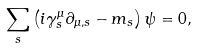Convert formula to latex. <formula><loc_0><loc_0><loc_500><loc_500>\sum _ { s } \left ( i \gamma ^ { \mu } _ { s } \partial _ { \mu , s } - m _ { s } \right ) \psi = 0 ,</formula> 